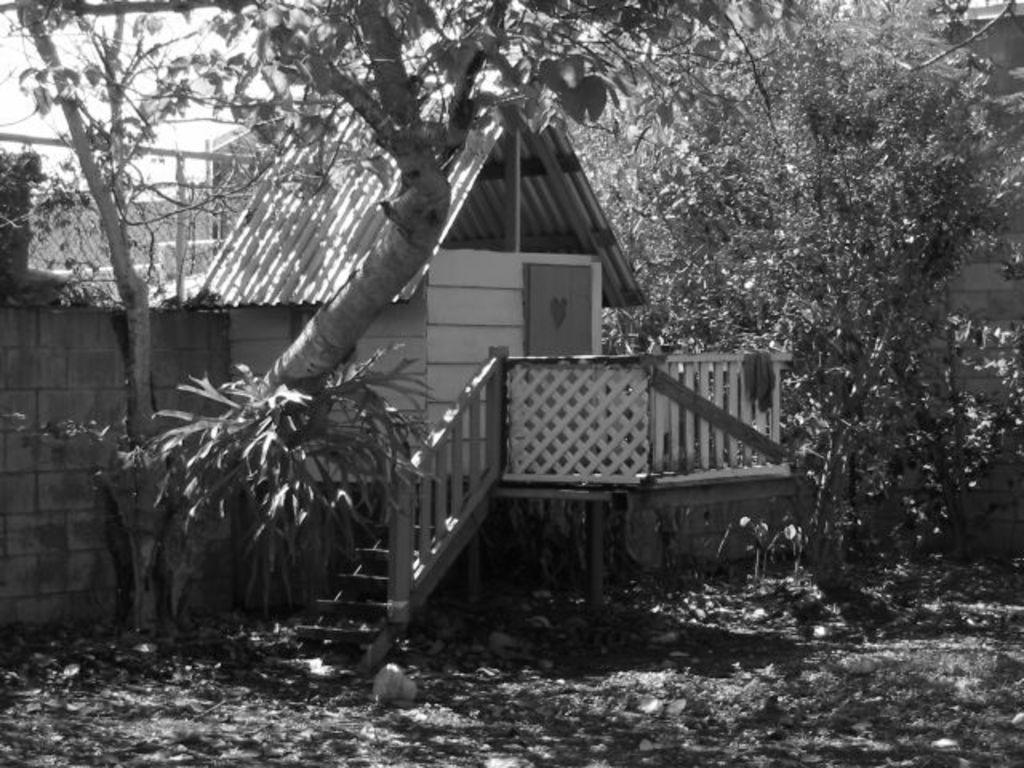How would you summarize this image in a sentence or two? In this image I can see a house, background I can see trees and the sky, and the image is in black and white. 